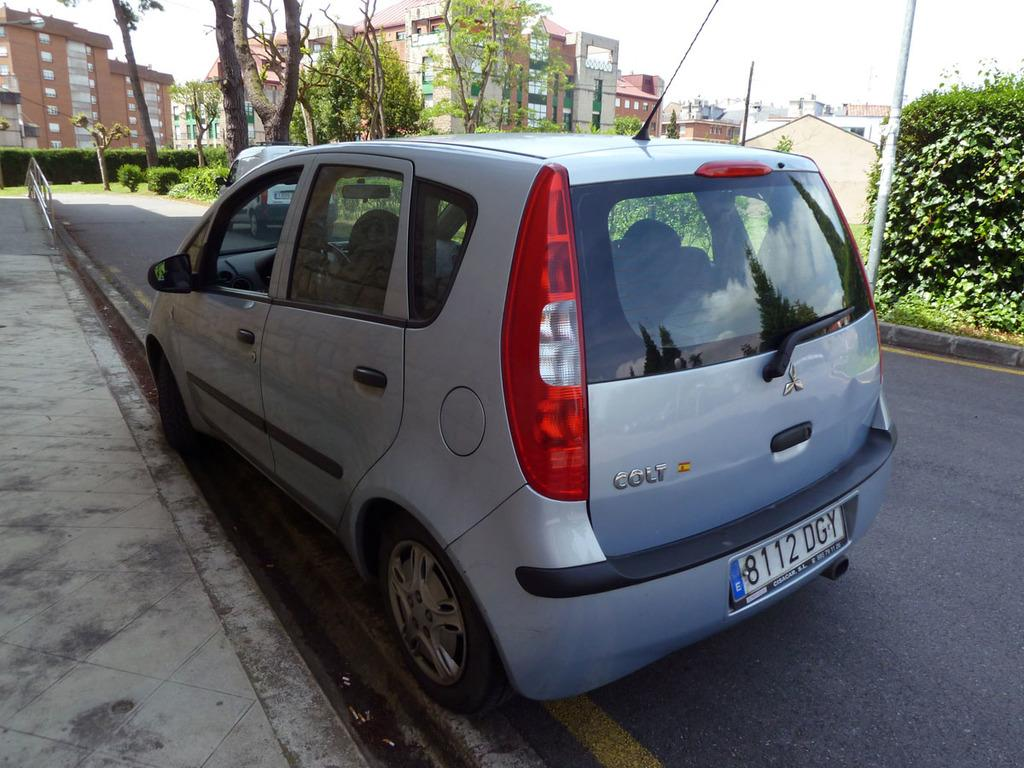What type of structures can be seen in the image? There are buildings in the image. What type of transportation is visible on the road in the image? There are motor vehicles on the road in the image. What type of vegetation is present in the image? There are trees in the image. What type of vertical structures can be seen in the image? There are poles in the image. What part of the natural environment is visible in the image? The sky is visible in the image. What type of hammer is being used to fix the tub in the image? There is no hammer or tub present in the image. What is the price of the item being sold in the image? There is no item being sold in the image. 